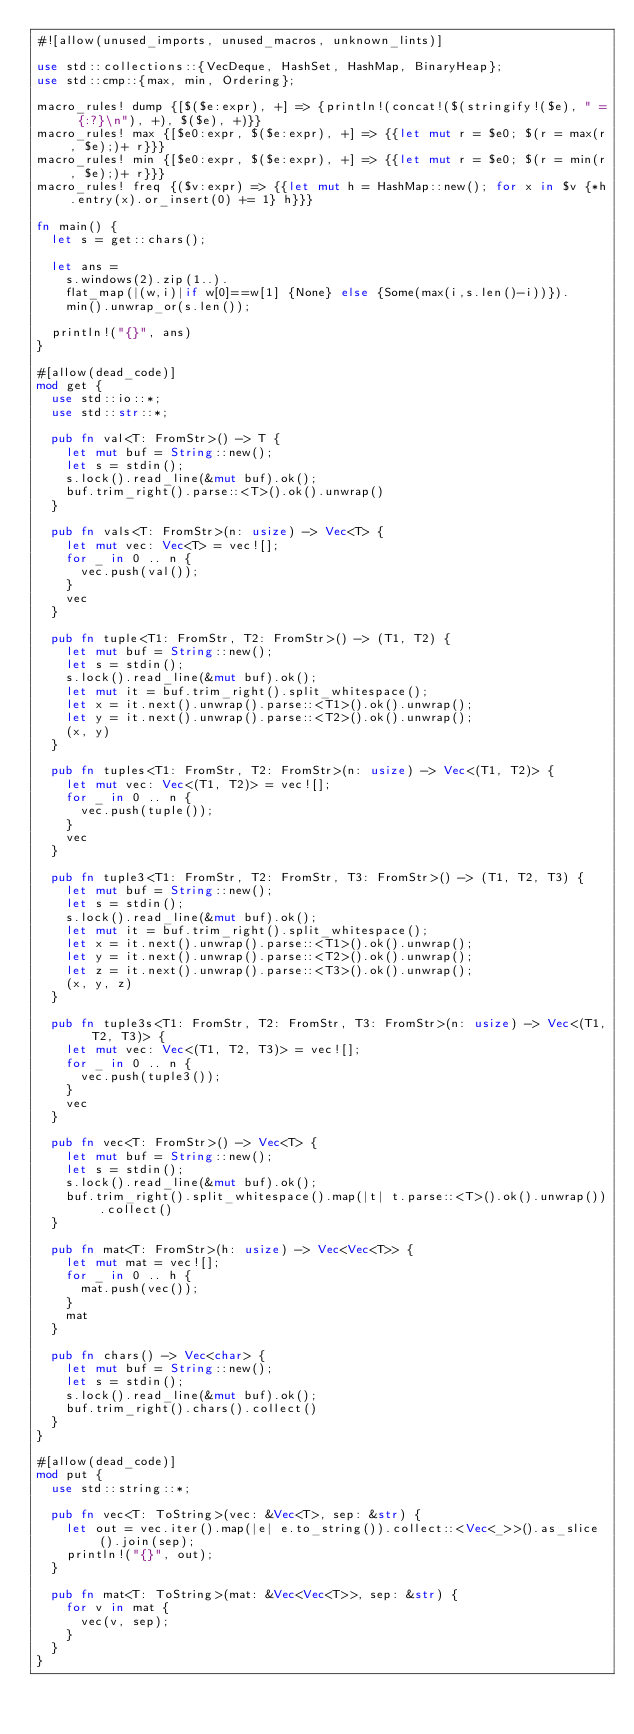<code> <loc_0><loc_0><loc_500><loc_500><_Rust_>#![allow(unused_imports, unused_macros, unknown_lints)]

use std::collections::{VecDeque, HashSet, HashMap, BinaryHeap};
use std::cmp::{max, min, Ordering};

macro_rules! dump {[$($e:expr), +] => {println!(concat!($(stringify!($e), " = {:?}\n"), +), $($e), +)}}
macro_rules! max {[$e0:expr, $($e:expr), +] => {{let mut r = $e0; $(r = max(r, $e);)+ r}}}
macro_rules! min {[$e0:expr, $($e:expr), +] => {{let mut r = $e0; $(r = min(r, $e);)+ r}}}
macro_rules! freq {($v:expr) => {{let mut h = HashMap::new(); for x in $v {*h.entry(x).or_insert(0) += 1} h}}}

fn main() {
  let s = get::chars();

  let ans =
    s.windows(2).zip(1..).
    flat_map(|(w,i)|if w[0]==w[1] {None} else {Some(max(i,s.len()-i))}).
    min().unwrap_or(s.len());

  println!("{}", ans)
}

#[allow(dead_code)]
mod get {
  use std::io::*;
  use std::str::*;

  pub fn val<T: FromStr>() -> T {
    let mut buf = String::new();
    let s = stdin();
    s.lock().read_line(&mut buf).ok();
    buf.trim_right().parse::<T>().ok().unwrap()
  }

  pub fn vals<T: FromStr>(n: usize) -> Vec<T> {
    let mut vec: Vec<T> = vec![];
    for _ in 0 .. n {
      vec.push(val());
    }
    vec
  }

  pub fn tuple<T1: FromStr, T2: FromStr>() -> (T1, T2) {
    let mut buf = String::new();
    let s = stdin();
    s.lock().read_line(&mut buf).ok();
    let mut it = buf.trim_right().split_whitespace();
    let x = it.next().unwrap().parse::<T1>().ok().unwrap();
    let y = it.next().unwrap().parse::<T2>().ok().unwrap();
    (x, y)
  }

  pub fn tuples<T1: FromStr, T2: FromStr>(n: usize) -> Vec<(T1, T2)> {
    let mut vec: Vec<(T1, T2)> = vec![];
    for _ in 0 .. n {
      vec.push(tuple());
    }
    vec
  }

  pub fn tuple3<T1: FromStr, T2: FromStr, T3: FromStr>() -> (T1, T2, T3) {
    let mut buf = String::new();
    let s = stdin();
    s.lock().read_line(&mut buf).ok();
    let mut it = buf.trim_right().split_whitespace();
    let x = it.next().unwrap().parse::<T1>().ok().unwrap();
    let y = it.next().unwrap().parse::<T2>().ok().unwrap();
    let z = it.next().unwrap().parse::<T3>().ok().unwrap();
    (x, y, z)
  }

  pub fn tuple3s<T1: FromStr, T2: FromStr, T3: FromStr>(n: usize) -> Vec<(T1, T2, T3)> {
    let mut vec: Vec<(T1, T2, T3)> = vec![];
    for _ in 0 .. n {
      vec.push(tuple3());
    }
    vec
  }

  pub fn vec<T: FromStr>() -> Vec<T> {
    let mut buf = String::new();
    let s = stdin();
    s.lock().read_line(&mut buf).ok();
    buf.trim_right().split_whitespace().map(|t| t.parse::<T>().ok().unwrap()).collect()
  }

  pub fn mat<T: FromStr>(h: usize) -> Vec<Vec<T>> {
    let mut mat = vec![];
    for _ in 0 .. h {
      mat.push(vec());
    }
    mat
  }

  pub fn chars() -> Vec<char> {
    let mut buf = String::new();
    let s = stdin();
    s.lock().read_line(&mut buf).ok();
    buf.trim_right().chars().collect()
  }
}

#[allow(dead_code)]
mod put {
  use std::string::*;

  pub fn vec<T: ToString>(vec: &Vec<T>, sep: &str) {
    let out = vec.iter().map(|e| e.to_string()).collect::<Vec<_>>().as_slice().join(sep);
    println!("{}", out);
  }

  pub fn mat<T: ToString>(mat: &Vec<Vec<T>>, sep: &str) {
    for v in mat {
      vec(v, sep);
    }
  }
}
</code> 